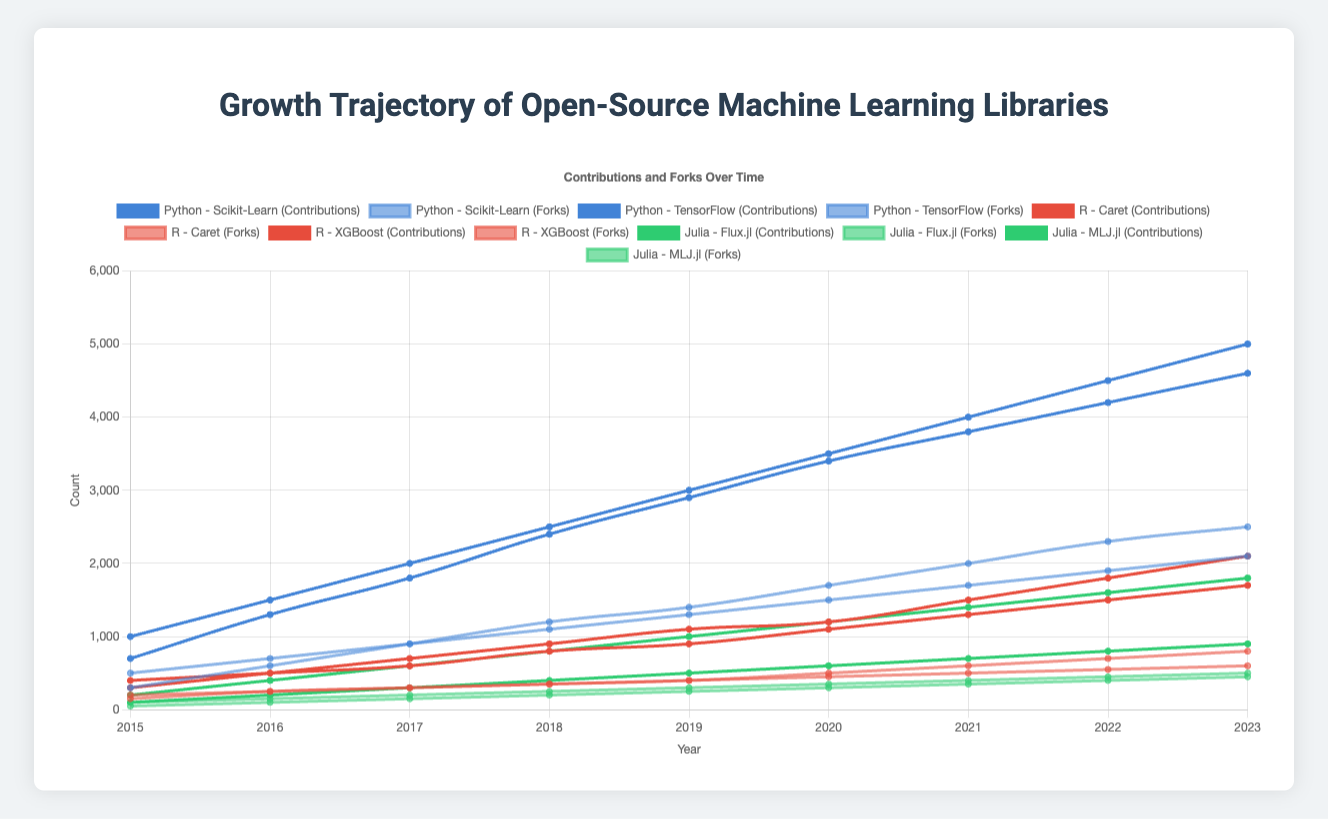Which library has the highest number of contributions in 2023? First, observe the contributions for 2023 in all libraries. Scikit-Learn has 5000, TensorFlow has 4600, Caret has 1700, XGBoost has 2100, Flux.jl has 1800, and MLJ.jl has 900. Scikit-Learn has the highest number.
Answer: Scikit-Learn How did the number of forks for MLJ.jl change from 2018 to 2023? Look at the number of forks for MLJ.jl in 2018 (200) and 2023 (450). The change can be calculated as 450 - 200 = 250.
Answer: Increased by 250 Compare the growth of contributions for TensorFlow and XGBoost between 2015 and 2023. TensorFlow has 700 contributions in 2015 and 4600 in 2023, growing by 4600 - 700 = 3900. XGBoost has 300 contributions in 2015 and 2100 in 2023, growing by 2100 - 300 = 1800. So, TensorFlow's growth is more significant.
Answer: TensorFlow grew by 3900, XGBoost by 1800. TensorFlow grew more What is the difference in the number of forks between Flux.jl and Caret in 2023? Check the number of forks for Flux.jl (500) and Caret (600) in 2023. The difference is calculated as 600 - 500 = 100.
Answer: 100 Which language had libraries with a steady increase in contributions across all years? Compare the trend lines of the libraries' contributions over time. Python (Scikit-Learn and TensorFlow), R (Caret and XGBoost), and Julia (Flux.jl and MLJ.jl) all show steady increases. However, Julia appears to have a more consistent upward trend with relatively smaller libraries.
Answer: Julia Which library had the most significant increase in forks from 2022 to 2023? Look at the change in the number of forks for each library from 2022 to 2023. Scikit-Learn changed from 1900 to 2100 (increase of 200), TensorFlow from 2300 to 2500 (increase of 200), Caret from 550 to 600 (increase of 50), XGBoost from 700 to 800 (increase of 100), Flux.jl from 450 to 500 (increase of 50), and MLJ.jl from 400 to 450 (increase of 50). The increase for Scikit-Learn and TensorFlow is the most significant.
Answer: Scikit-Learn and TensorFlow What is the ratio of contributions to forks for Flux.jl in 2020? For 2020, Flux.jl has 1200 contributions and 350 forks. The ratio is calculated as 1200 / 350 ≈ 3.43.
Answer: Approximately 3.43 Between Scikit-Learn and TensorFlow, which library had a faster rate of growth in contributions between 2018 and 2020? For Scikit-Learn, contributions went from 2500 in 2018 to 3500 in 2020 (growth of 1000). For TensorFlow, contributions went from 2400 in 2018 to 3400 in 2020 (growth of 1000). Both libraries had the same rate of growth.
Answer: Equal rate How does the number of forks in 2023 for Scikit-Learn compare to the total number of contributions in 2023 for all Julia libraries? Scikit-Learn has 2100 forks in 2023. Flux.jl has 1800 and MLJ.jl has 900 contributions in 2023, together totaling 1800 + 900 = 2700 contributions. Hence, the forks for Scikit-Learn are fewer.
Answer: Julia libraries have more 